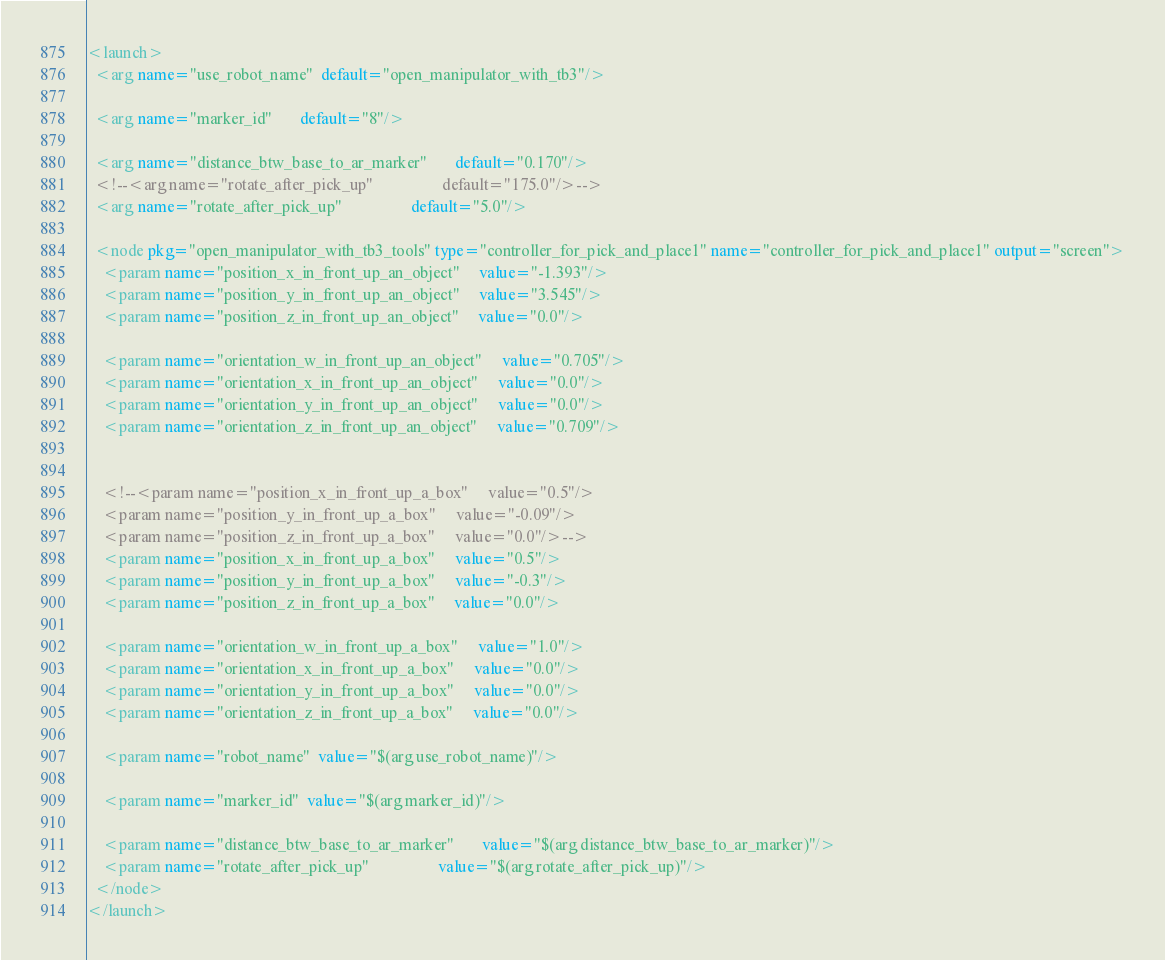<code> <loc_0><loc_0><loc_500><loc_500><_XML_><launch>
  <arg name="use_robot_name"  default="open_manipulator_with_tb3"/>

  <arg name="marker_id"       default="8"/>

  <arg name="distance_btw_base_to_ar_marker"       default="0.170"/>
  <!--<arg name="rotate_after_pick_up"                 default="175.0"/>-->
  <arg name="rotate_after_pick_up"                 default="5.0"/>

  <node pkg="open_manipulator_with_tb3_tools" type="controller_for_pick_and_place1" name="controller_for_pick_and_place1" output="screen">
    <param name="position_x_in_front_up_an_object"     value="-1.393"/>
    <param name="position_y_in_front_up_an_object"     value="3.545"/>
    <param name="position_z_in_front_up_an_object"     value="0.0"/>

    <param name="orientation_w_in_front_up_an_object"     value="0.705"/>
    <param name="orientation_x_in_front_up_an_object"     value="0.0"/>
    <param name="orientation_y_in_front_up_an_object"     value="0.0"/>
    <param name="orientation_z_in_front_up_an_object"     value="0.709"/>


    <!--<param name="position_x_in_front_up_a_box"     value="0.5"/>
    <param name="position_y_in_front_up_a_box"     value="-0.09"/>
    <param name="position_z_in_front_up_a_box"     value="0.0"/>-->
    <param name="position_x_in_front_up_a_box"     value="0.5"/>
    <param name="position_y_in_front_up_a_box"     value="-0.3"/>
    <param name="position_z_in_front_up_a_box"     value="0.0"/>

    <param name="orientation_w_in_front_up_a_box"     value="1.0"/>
    <param name="orientation_x_in_front_up_a_box"     value="0.0"/>
    <param name="orientation_y_in_front_up_a_box"     value="0.0"/>
    <param name="orientation_z_in_front_up_a_box"     value="0.0"/>

    <param name="robot_name"  value="$(arg use_robot_name)"/>

    <param name="marker_id"  value="$(arg marker_id)"/>

    <param name="distance_btw_base_to_ar_marker"       value="$(arg distance_btw_base_to_ar_marker)"/>
    <param name="rotate_after_pick_up"                 value="$(arg rotate_after_pick_up)"/>
  </node>
</launch>
</code> 